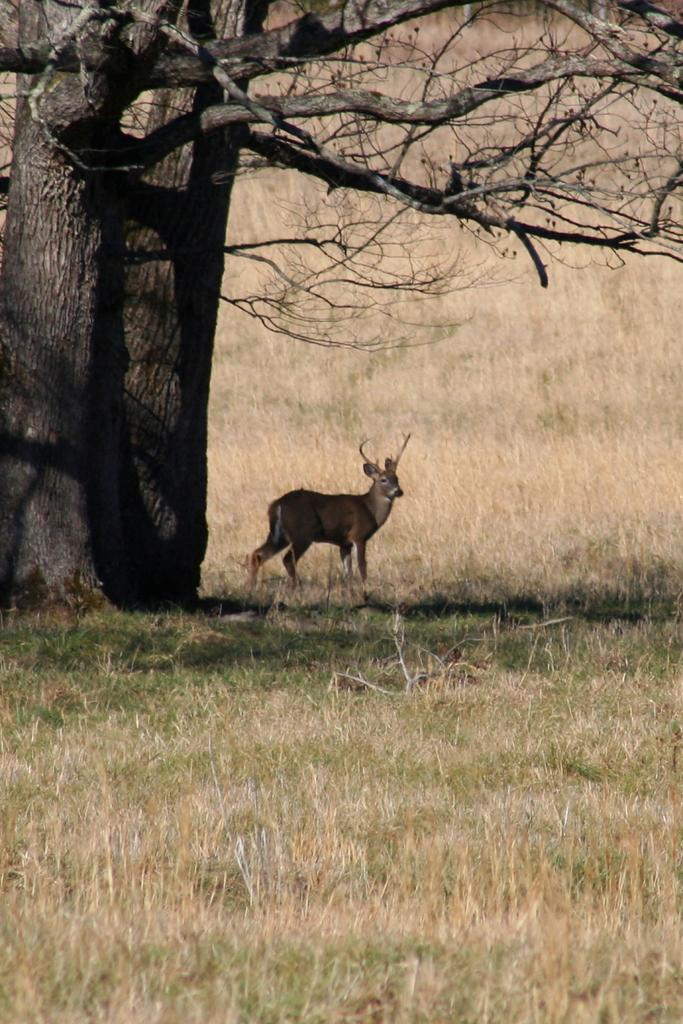What animal is in the center of the image? There is a deer in the center of the image. What type of vegetation is at the bottom of the image? Grass is present at the bottom of the image. What can be seen in the background of the image? There are trees in the background of the image. What country is the deer from in the image? The image does not provide information about the country of origin for the deer. 